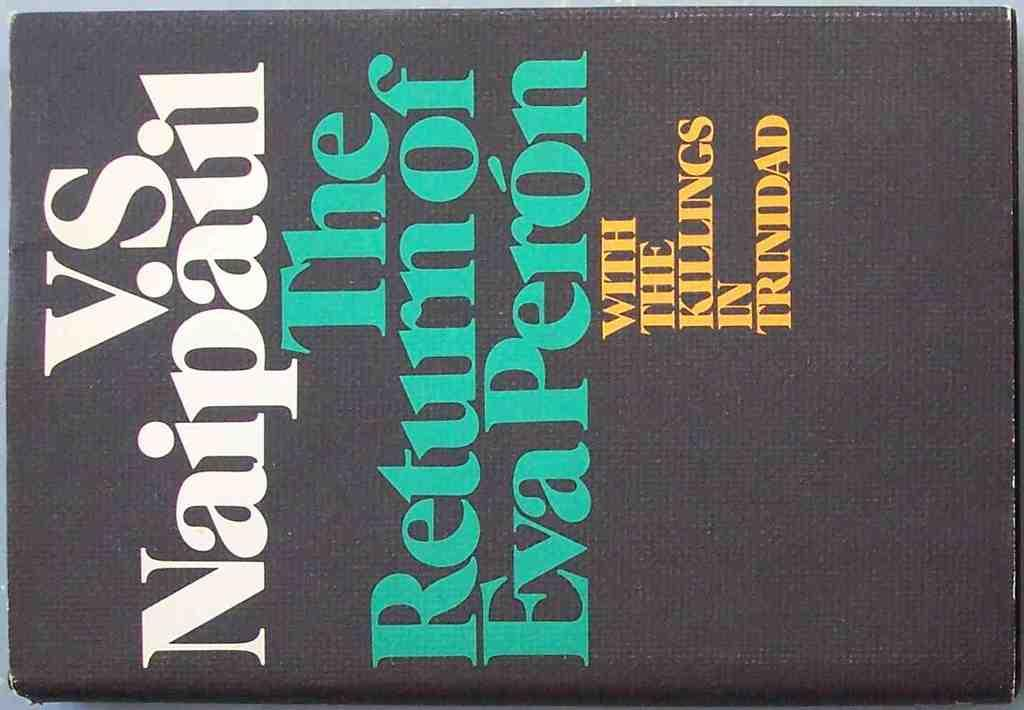<image>
Present a compact description of the photo's key features. Black book with a cover that says "The Return of Eva Peron". 